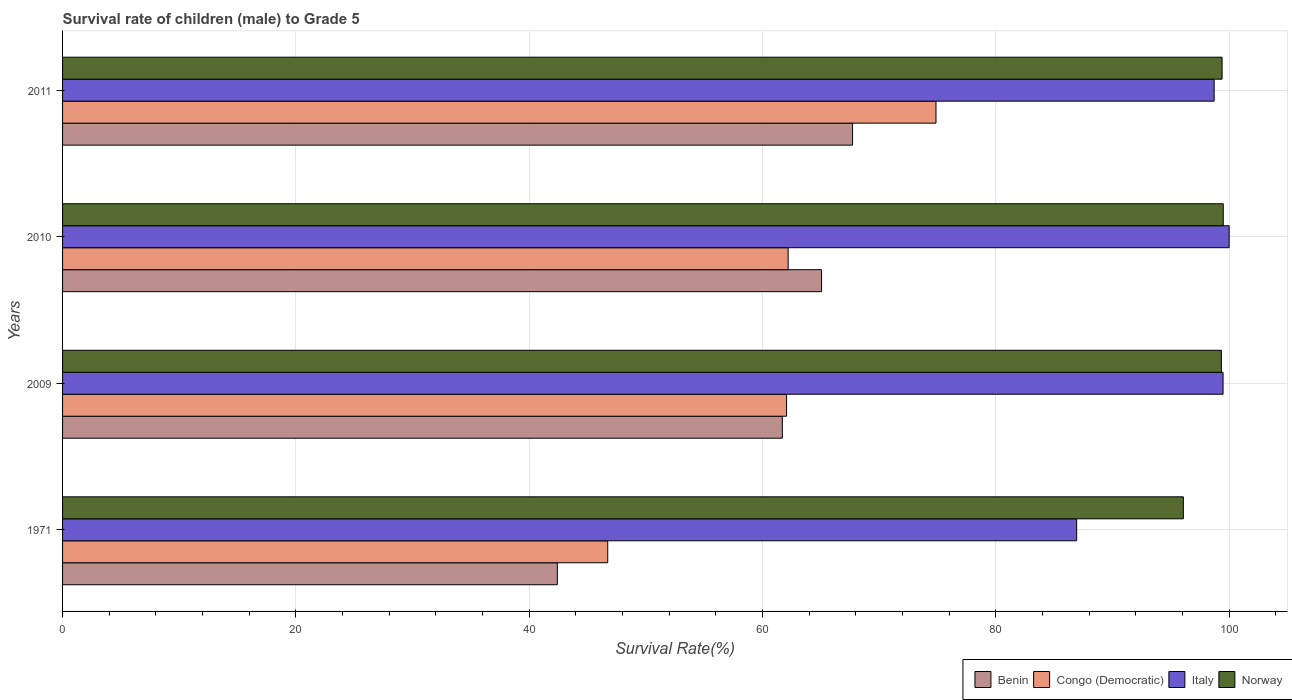How many different coloured bars are there?
Offer a terse response. 4. How many groups of bars are there?
Your answer should be compact. 4. Are the number of bars on each tick of the Y-axis equal?
Your answer should be compact. Yes. What is the label of the 4th group of bars from the top?
Ensure brevity in your answer.  1971. In how many cases, is the number of bars for a given year not equal to the number of legend labels?
Your response must be concise. 0. What is the survival rate of male children to grade 5 in Congo (Democratic) in 2011?
Provide a succinct answer. 74.87. Across all years, what is the maximum survival rate of male children to grade 5 in Congo (Democratic)?
Give a very brief answer. 74.87. Across all years, what is the minimum survival rate of male children to grade 5 in Congo (Democratic)?
Keep it short and to the point. 46.73. In which year was the survival rate of male children to grade 5 in Benin minimum?
Your response must be concise. 1971. What is the total survival rate of male children to grade 5 in Italy in the graph?
Provide a short and direct response. 385.12. What is the difference between the survival rate of male children to grade 5 in Italy in 2009 and that in 2010?
Your answer should be compact. -0.52. What is the difference between the survival rate of male children to grade 5 in Congo (Democratic) in 1971 and the survival rate of male children to grade 5 in Benin in 2010?
Provide a succinct answer. -18.33. What is the average survival rate of male children to grade 5 in Norway per year?
Your answer should be compact. 98.57. In the year 2010, what is the difference between the survival rate of male children to grade 5 in Norway and survival rate of male children to grade 5 in Benin?
Ensure brevity in your answer.  34.43. What is the ratio of the survival rate of male children to grade 5 in Congo (Democratic) in 2009 to that in 2010?
Your answer should be compact. 1. Is the difference between the survival rate of male children to grade 5 in Norway in 1971 and 2011 greater than the difference between the survival rate of male children to grade 5 in Benin in 1971 and 2011?
Provide a short and direct response. Yes. What is the difference between the highest and the second highest survival rate of male children to grade 5 in Norway?
Your answer should be very brief. 0.1. What is the difference between the highest and the lowest survival rate of male children to grade 5 in Congo (Democratic)?
Offer a very short reply. 28.14. What does the 4th bar from the top in 2011 represents?
Your answer should be compact. Benin. What does the 1st bar from the bottom in 2011 represents?
Provide a short and direct response. Benin. Are all the bars in the graph horizontal?
Your response must be concise. Yes. How many years are there in the graph?
Your response must be concise. 4. What is the difference between two consecutive major ticks on the X-axis?
Your answer should be compact. 20. Are the values on the major ticks of X-axis written in scientific E-notation?
Keep it short and to the point. No. Does the graph contain any zero values?
Your response must be concise. No. How are the legend labels stacked?
Give a very brief answer. Horizontal. What is the title of the graph?
Offer a terse response. Survival rate of children (male) to Grade 5. What is the label or title of the X-axis?
Make the answer very short. Survival Rate(%). What is the label or title of the Y-axis?
Give a very brief answer. Years. What is the Survival Rate(%) of Benin in 1971?
Make the answer very short. 42.41. What is the Survival Rate(%) in Congo (Democratic) in 1971?
Offer a terse response. 46.73. What is the Survival Rate(%) of Italy in 1971?
Provide a short and direct response. 86.93. What is the Survival Rate(%) of Norway in 1971?
Provide a succinct answer. 96.07. What is the Survival Rate(%) in Benin in 2009?
Provide a short and direct response. 61.7. What is the Survival Rate(%) of Congo (Democratic) in 2009?
Provide a short and direct response. 62.06. What is the Survival Rate(%) of Italy in 2009?
Your response must be concise. 99.48. What is the Survival Rate(%) in Norway in 2009?
Ensure brevity in your answer.  99.33. What is the Survival Rate(%) of Benin in 2010?
Provide a succinct answer. 65.06. What is the Survival Rate(%) of Congo (Democratic) in 2010?
Your response must be concise. 62.2. What is the Survival Rate(%) in Italy in 2010?
Give a very brief answer. 100. What is the Survival Rate(%) of Norway in 2010?
Your answer should be very brief. 99.49. What is the Survival Rate(%) in Benin in 2011?
Ensure brevity in your answer.  67.72. What is the Survival Rate(%) in Congo (Democratic) in 2011?
Keep it short and to the point. 74.87. What is the Survival Rate(%) of Italy in 2011?
Offer a very short reply. 98.71. What is the Survival Rate(%) of Norway in 2011?
Provide a short and direct response. 99.39. Across all years, what is the maximum Survival Rate(%) in Benin?
Give a very brief answer. 67.72. Across all years, what is the maximum Survival Rate(%) in Congo (Democratic)?
Your answer should be compact. 74.87. Across all years, what is the maximum Survival Rate(%) of Italy?
Ensure brevity in your answer.  100. Across all years, what is the maximum Survival Rate(%) in Norway?
Offer a terse response. 99.49. Across all years, what is the minimum Survival Rate(%) in Benin?
Offer a terse response. 42.41. Across all years, what is the minimum Survival Rate(%) of Congo (Democratic)?
Your answer should be very brief. 46.73. Across all years, what is the minimum Survival Rate(%) of Italy?
Offer a very short reply. 86.93. Across all years, what is the minimum Survival Rate(%) in Norway?
Your answer should be very brief. 96.07. What is the total Survival Rate(%) of Benin in the graph?
Your answer should be very brief. 236.89. What is the total Survival Rate(%) of Congo (Democratic) in the graph?
Make the answer very short. 245.86. What is the total Survival Rate(%) in Italy in the graph?
Keep it short and to the point. 385.12. What is the total Survival Rate(%) of Norway in the graph?
Provide a short and direct response. 394.29. What is the difference between the Survival Rate(%) of Benin in 1971 and that in 2009?
Offer a very short reply. -19.29. What is the difference between the Survival Rate(%) of Congo (Democratic) in 1971 and that in 2009?
Your answer should be very brief. -15.33. What is the difference between the Survival Rate(%) of Italy in 1971 and that in 2009?
Provide a succinct answer. -12.55. What is the difference between the Survival Rate(%) in Norway in 1971 and that in 2009?
Keep it short and to the point. -3.26. What is the difference between the Survival Rate(%) in Benin in 1971 and that in 2010?
Make the answer very short. -22.65. What is the difference between the Survival Rate(%) in Congo (Democratic) in 1971 and that in 2010?
Offer a very short reply. -15.47. What is the difference between the Survival Rate(%) in Italy in 1971 and that in 2010?
Keep it short and to the point. -13.07. What is the difference between the Survival Rate(%) in Norway in 1971 and that in 2010?
Your answer should be very brief. -3.42. What is the difference between the Survival Rate(%) of Benin in 1971 and that in 2011?
Give a very brief answer. -25.31. What is the difference between the Survival Rate(%) in Congo (Democratic) in 1971 and that in 2011?
Keep it short and to the point. -28.14. What is the difference between the Survival Rate(%) in Italy in 1971 and that in 2011?
Ensure brevity in your answer.  -11.79. What is the difference between the Survival Rate(%) in Norway in 1971 and that in 2011?
Make the answer very short. -3.32. What is the difference between the Survival Rate(%) of Benin in 2009 and that in 2010?
Make the answer very short. -3.36. What is the difference between the Survival Rate(%) of Congo (Democratic) in 2009 and that in 2010?
Make the answer very short. -0.14. What is the difference between the Survival Rate(%) of Italy in 2009 and that in 2010?
Offer a terse response. -0.52. What is the difference between the Survival Rate(%) of Norway in 2009 and that in 2010?
Make the answer very short. -0.16. What is the difference between the Survival Rate(%) in Benin in 2009 and that in 2011?
Your answer should be compact. -6.02. What is the difference between the Survival Rate(%) of Congo (Democratic) in 2009 and that in 2011?
Your response must be concise. -12.81. What is the difference between the Survival Rate(%) of Italy in 2009 and that in 2011?
Keep it short and to the point. 0.76. What is the difference between the Survival Rate(%) of Norway in 2009 and that in 2011?
Provide a short and direct response. -0.06. What is the difference between the Survival Rate(%) of Benin in 2010 and that in 2011?
Ensure brevity in your answer.  -2.66. What is the difference between the Survival Rate(%) of Congo (Democratic) in 2010 and that in 2011?
Make the answer very short. -12.67. What is the difference between the Survival Rate(%) of Italy in 2010 and that in 2011?
Make the answer very short. 1.29. What is the difference between the Survival Rate(%) in Norway in 2010 and that in 2011?
Provide a short and direct response. 0.1. What is the difference between the Survival Rate(%) in Benin in 1971 and the Survival Rate(%) in Congo (Democratic) in 2009?
Keep it short and to the point. -19.65. What is the difference between the Survival Rate(%) of Benin in 1971 and the Survival Rate(%) of Italy in 2009?
Your answer should be compact. -57.07. What is the difference between the Survival Rate(%) of Benin in 1971 and the Survival Rate(%) of Norway in 2009?
Offer a very short reply. -56.92. What is the difference between the Survival Rate(%) of Congo (Democratic) in 1971 and the Survival Rate(%) of Italy in 2009?
Ensure brevity in your answer.  -52.75. What is the difference between the Survival Rate(%) in Congo (Democratic) in 1971 and the Survival Rate(%) in Norway in 2009?
Provide a succinct answer. -52.6. What is the difference between the Survival Rate(%) in Italy in 1971 and the Survival Rate(%) in Norway in 2009?
Make the answer very short. -12.41. What is the difference between the Survival Rate(%) in Benin in 1971 and the Survival Rate(%) in Congo (Democratic) in 2010?
Your response must be concise. -19.79. What is the difference between the Survival Rate(%) of Benin in 1971 and the Survival Rate(%) of Italy in 2010?
Provide a succinct answer. -57.59. What is the difference between the Survival Rate(%) of Benin in 1971 and the Survival Rate(%) of Norway in 2010?
Offer a very short reply. -57.08. What is the difference between the Survival Rate(%) in Congo (Democratic) in 1971 and the Survival Rate(%) in Italy in 2010?
Provide a short and direct response. -53.27. What is the difference between the Survival Rate(%) in Congo (Democratic) in 1971 and the Survival Rate(%) in Norway in 2010?
Keep it short and to the point. -52.76. What is the difference between the Survival Rate(%) in Italy in 1971 and the Survival Rate(%) in Norway in 2010?
Ensure brevity in your answer.  -12.56. What is the difference between the Survival Rate(%) in Benin in 1971 and the Survival Rate(%) in Congo (Democratic) in 2011?
Provide a short and direct response. -32.46. What is the difference between the Survival Rate(%) of Benin in 1971 and the Survival Rate(%) of Italy in 2011?
Offer a very short reply. -56.3. What is the difference between the Survival Rate(%) in Benin in 1971 and the Survival Rate(%) in Norway in 2011?
Make the answer very short. -56.98. What is the difference between the Survival Rate(%) of Congo (Democratic) in 1971 and the Survival Rate(%) of Italy in 2011?
Offer a very short reply. -51.98. What is the difference between the Survival Rate(%) of Congo (Democratic) in 1971 and the Survival Rate(%) of Norway in 2011?
Your answer should be very brief. -52.66. What is the difference between the Survival Rate(%) of Italy in 1971 and the Survival Rate(%) of Norway in 2011?
Provide a short and direct response. -12.46. What is the difference between the Survival Rate(%) of Benin in 2009 and the Survival Rate(%) of Congo (Democratic) in 2010?
Your answer should be very brief. -0.5. What is the difference between the Survival Rate(%) in Benin in 2009 and the Survival Rate(%) in Italy in 2010?
Your answer should be very brief. -38.3. What is the difference between the Survival Rate(%) of Benin in 2009 and the Survival Rate(%) of Norway in 2010?
Offer a very short reply. -37.79. What is the difference between the Survival Rate(%) in Congo (Democratic) in 2009 and the Survival Rate(%) in Italy in 2010?
Offer a very short reply. -37.94. What is the difference between the Survival Rate(%) of Congo (Democratic) in 2009 and the Survival Rate(%) of Norway in 2010?
Offer a very short reply. -37.43. What is the difference between the Survival Rate(%) in Italy in 2009 and the Survival Rate(%) in Norway in 2010?
Your answer should be very brief. -0.02. What is the difference between the Survival Rate(%) in Benin in 2009 and the Survival Rate(%) in Congo (Democratic) in 2011?
Your answer should be compact. -13.17. What is the difference between the Survival Rate(%) of Benin in 2009 and the Survival Rate(%) of Italy in 2011?
Ensure brevity in your answer.  -37.02. What is the difference between the Survival Rate(%) in Benin in 2009 and the Survival Rate(%) in Norway in 2011?
Provide a short and direct response. -37.69. What is the difference between the Survival Rate(%) of Congo (Democratic) in 2009 and the Survival Rate(%) of Italy in 2011?
Ensure brevity in your answer.  -36.65. What is the difference between the Survival Rate(%) of Congo (Democratic) in 2009 and the Survival Rate(%) of Norway in 2011?
Provide a short and direct response. -37.33. What is the difference between the Survival Rate(%) of Italy in 2009 and the Survival Rate(%) of Norway in 2011?
Offer a very short reply. 0.08. What is the difference between the Survival Rate(%) in Benin in 2010 and the Survival Rate(%) in Congo (Democratic) in 2011?
Your response must be concise. -9.81. What is the difference between the Survival Rate(%) in Benin in 2010 and the Survival Rate(%) in Italy in 2011?
Offer a terse response. -33.65. What is the difference between the Survival Rate(%) of Benin in 2010 and the Survival Rate(%) of Norway in 2011?
Provide a succinct answer. -34.33. What is the difference between the Survival Rate(%) in Congo (Democratic) in 2010 and the Survival Rate(%) in Italy in 2011?
Your answer should be very brief. -36.52. What is the difference between the Survival Rate(%) of Congo (Democratic) in 2010 and the Survival Rate(%) of Norway in 2011?
Your response must be concise. -37.2. What is the difference between the Survival Rate(%) of Italy in 2010 and the Survival Rate(%) of Norway in 2011?
Your answer should be compact. 0.61. What is the average Survival Rate(%) in Benin per year?
Offer a terse response. 59.22. What is the average Survival Rate(%) in Congo (Democratic) per year?
Provide a succinct answer. 61.46. What is the average Survival Rate(%) of Italy per year?
Your response must be concise. 96.28. What is the average Survival Rate(%) in Norway per year?
Ensure brevity in your answer.  98.57. In the year 1971, what is the difference between the Survival Rate(%) in Benin and Survival Rate(%) in Congo (Democratic)?
Keep it short and to the point. -4.32. In the year 1971, what is the difference between the Survival Rate(%) in Benin and Survival Rate(%) in Italy?
Your answer should be compact. -44.52. In the year 1971, what is the difference between the Survival Rate(%) in Benin and Survival Rate(%) in Norway?
Offer a very short reply. -53.66. In the year 1971, what is the difference between the Survival Rate(%) of Congo (Democratic) and Survival Rate(%) of Italy?
Offer a terse response. -40.2. In the year 1971, what is the difference between the Survival Rate(%) in Congo (Democratic) and Survival Rate(%) in Norway?
Your response must be concise. -49.34. In the year 1971, what is the difference between the Survival Rate(%) of Italy and Survival Rate(%) of Norway?
Make the answer very short. -9.14. In the year 2009, what is the difference between the Survival Rate(%) in Benin and Survival Rate(%) in Congo (Democratic)?
Provide a short and direct response. -0.36. In the year 2009, what is the difference between the Survival Rate(%) of Benin and Survival Rate(%) of Italy?
Keep it short and to the point. -37.78. In the year 2009, what is the difference between the Survival Rate(%) in Benin and Survival Rate(%) in Norway?
Ensure brevity in your answer.  -37.64. In the year 2009, what is the difference between the Survival Rate(%) in Congo (Democratic) and Survival Rate(%) in Italy?
Keep it short and to the point. -37.42. In the year 2009, what is the difference between the Survival Rate(%) of Congo (Democratic) and Survival Rate(%) of Norway?
Provide a short and direct response. -37.27. In the year 2009, what is the difference between the Survival Rate(%) of Italy and Survival Rate(%) of Norway?
Make the answer very short. 0.14. In the year 2010, what is the difference between the Survival Rate(%) in Benin and Survival Rate(%) in Congo (Democratic)?
Give a very brief answer. 2.86. In the year 2010, what is the difference between the Survival Rate(%) of Benin and Survival Rate(%) of Italy?
Offer a terse response. -34.94. In the year 2010, what is the difference between the Survival Rate(%) of Benin and Survival Rate(%) of Norway?
Make the answer very short. -34.43. In the year 2010, what is the difference between the Survival Rate(%) of Congo (Democratic) and Survival Rate(%) of Italy?
Offer a very short reply. -37.8. In the year 2010, what is the difference between the Survival Rate(%) of Congo (Democratic) and Survival Rate(%) of Norway?
Your answer should be compact. -37.3. In the year 2010, what is the difference between the Survival Rate(%) in Italy and Survival Rate(%) in Norway?
Offer a terse response. 0.51. In the year 2011, what is the difference between the Survival Rate(%) in Benin and Survival Rate(%) in Congo (Democratic)?
Your answer should be very brief. -7.15. In the year 2011, what is the difference between the Survival Rate(%) in Benin and Survival Rate(%) in Italy?
Keep it short and to the point. -31. In the year 2011, what is the difference between the Survival Rate(%) of Benin and Survival Rate(%) of Norway?
Your answer should be compact. -31.67. In the year 2011, what is the difference between the Survival Rate(%) in Congo (Democratic) and Survival Rate(%) in Italy?
Offer a very short reply. -23.85. In the year 2011, what is the difference between the Survival Rate(%) in Congo (Democratic) and Survival Rate(%) in Norway?
Your response must be concise. -24.52. In the year 2011, what is the difference between the Survival Rate(%) in Italy and Survival Rate(%) in Norway?
Ensure brevity in your answer.  -0.68. What is the ratio of the Survival Rate(%) of Benin in 1971 to that in 2009?
Offer a very short reply. 0.69. What is the ratio of the Survival Rate(%) in Congo (Democratic) in 1971 to that in 2009?
Offer a very short reply. 0.75. What is the ratio of the Survival Rate(%) in Italy in 1971 to that in 2009?
Keep it short and to the point. 0.87. What is the ratio of the Survival Rate(%) in Norway in 1971 to that in 2009?
Your answer should be very brief. 0.97. What is the ratio of the Survival Rate(%) in Benin in 1971 to that in 2010?
Offer a terse response. 0.65. What is the ratio of the Survival Rate(%) of Congo (Democratic) in 1971 to that in 2010?
Make the answer very short. 0.75. What is the ratio of the Survival Rate(%) in Italy in 1971 to that in 2010?
Make the answer very short. 0.87. What is the ratio of the Survival Rate(%) of Norway in 1971 to that in 2010?
Your answer should be very brief. 0.97. What is the ratio of the Survival Rate(%) of Benin in 1971 to that in 2011?
Provide a succinct answer. 0.63. What is the ratio of the Survival Rate(%) in Congo (Democratic) in 1971 to that in 2011?
Offer a very short reply. 0.62. What is the ratio of the Survival Rate(%) in Italy in 1971 to that in 2011?
Offer a terse response. 0.88. What is the ratio of the Survival Rate(%) of Norway in 1971 to that in 2011?
Provide a succinct answer. 0.97. What is the ratio of the Survival Rate(%) in Benin in 2009 to that in 2010?
Your answer should be compact. 0.95. What is the ratio of the Survival Rate(%) in Congo (Democratic) in 2009 to that in 2010?
Keep it short and to the point. 1. What is the ratio of the Survival Rate(%) of Benin in 2009 to that in 2011?
Provide a succinct answer. 0.91. What is the ratio of the Survival Rate(%) in Congo (Democratic) in 2009 to that in 2011?
Provide a short and direct response. 0.83. What is the ratio of the Survival Rate(%) in Italy in 2009 to that in 2011?
Make the answer very short. 1.01. What is the ratio of the Survival Rate(%) of Benin in 2010 to that in 2011?
Keep it short and to the point. 0.96. What is the ratio of the Survival Rate(%) in Congo (Democratic) in 2010 to that in 2011?
Provide a succinct answer. 0.83. What is the ratio of the Survival Rate(%) of Italy in 2010 to that in 2011?
Give a very brief answer. 1.01. What is the difference between the highest and the second highest Survival Rate(%) in Benin?
Give a very brief answer. 2.66. What is the difference between the highest and the second highest Survival Rate(%) of Congo (Democratic)?
Ensure brevity in your answer.  12.67. What is the difference between the highest and the second highest Survival Rate(%) of Italy?
Your response must be concise. 0.52. What is the difference between the highest and the second highest Survival Rate(%) in Norway?
Provide a short and direct response. 0.1. What is the difference between the highest and the lowest Survival Rate(%) of Benin?
Your answer should be compact. 25.31. What is the difference between the highest and the lowest Survival Rate(%) in Congo (Democratic)?
Ensure brevity in your answer.  28.14. What is the difference between the highest and the lowest Survival Rate(%) of Italy?
Make the answer very short. 13.07. What is the difference between the highest and the lowest Survival Rate(%) in Norway?
Give a very brief answer. 3.42. 